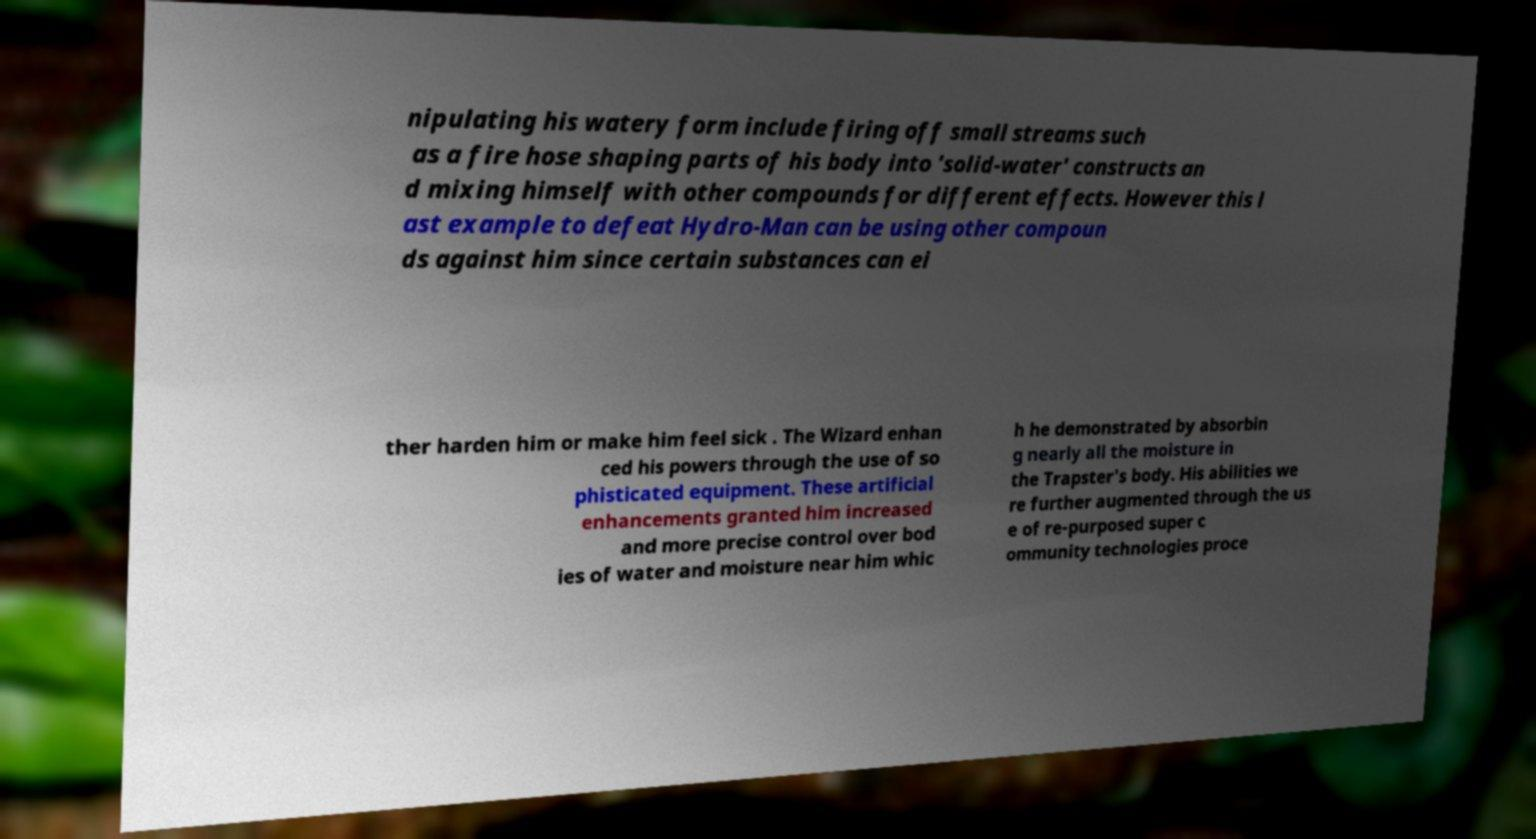I need the written content from this picture converted into text. Can you do that? nipulating his watery form include firing off small streams such as a fire hose shaping parts of his body into 'solid-water' constructs an d mixing himself with other compounds for different effects. However this l ast example to defeat Hydro-Man can be using other compoun ds against him since certain substances can ei ther harden him or make him feel sick . The Wizard enhan ced his powers through the use of so phisticated equipment. These artificial enhancements granted him increased and more precise control over bod ies of water and moisture near him whic h he demonstrated by absorbin g nearly all the moisture in the Trapster's body. His abilities we re further augmented through the us e of re-purposed super c ommunity technologies proce 